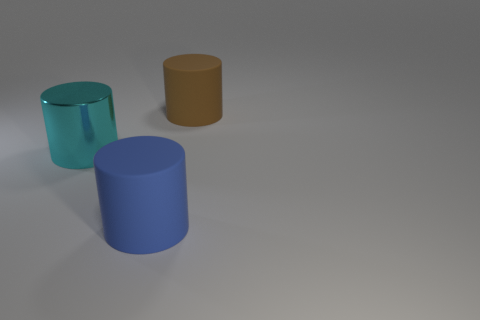Add 1 small yellow balls. How many objects exist? 4 Subtract 0 cyan blocks. How many objects are left? 3 Subtract all cyan metallic objects. Subtract all blue matte objects. How many objects are left? 1 Add 3 big objects. How many big objects are left? 6 Add 1 cyan rubber cubes. How many cyan rubber cubes exist? 1 